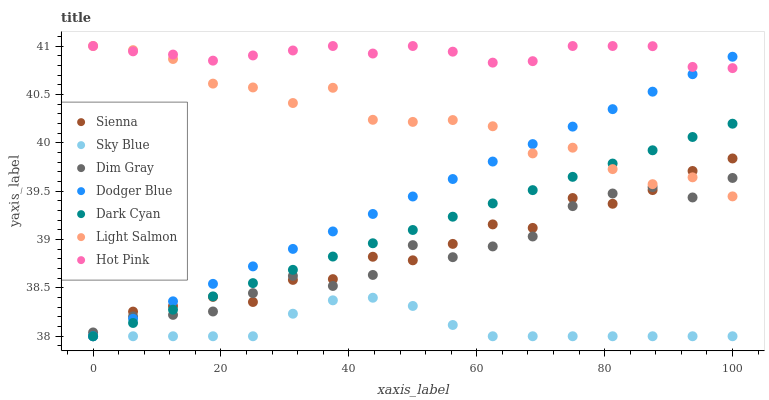Does Sky Blue have the minimum area under the curve?
Answer yes or no. Yes. Does Hot Pink have the maximum area under the curve?
Answer yes or no. Yes. Does Dim Gray have the minimum area under the curve?
Answer yes or no. No. Does Dim Gray have the maximum area under the curve?
Answer yes or no. No. Is Dodger Blue the smoothest?
Answer yes or no. Yes. Is Light Salmon the roughest?
Answer yes or no. Yes. Is Dim Gray the smoothest?
Answer yes or no. No. Is Dim Gray the roughest?
Answer yes or no. No. Does Sienna have the lowest value?
Answer yes or no. Yes. Does Dim Gray have the lowest value?
Answer yes or no. No. Does Hot Pink have the highest value?
Answer yes or no. Yes. Does Dim Gray have the highest value?
Answer yes or no. No. Is Dark Cyan less than Hot Pink?
Answer yes or no. Yes. Is Dim Gray greater than Sky Blue?
Answer yes or no. Yes. Does Hot Pink intersect Light Salmon?
Answer yes or no. Yes. Is Hot Pink less than Light Salmon?
Answer yes or no. No. Is Hot Pink greater than Light Salmon?
Answer yes or no. No. Does Dark Cyan intersect Hot Pink?
Answer yes or no. No. 